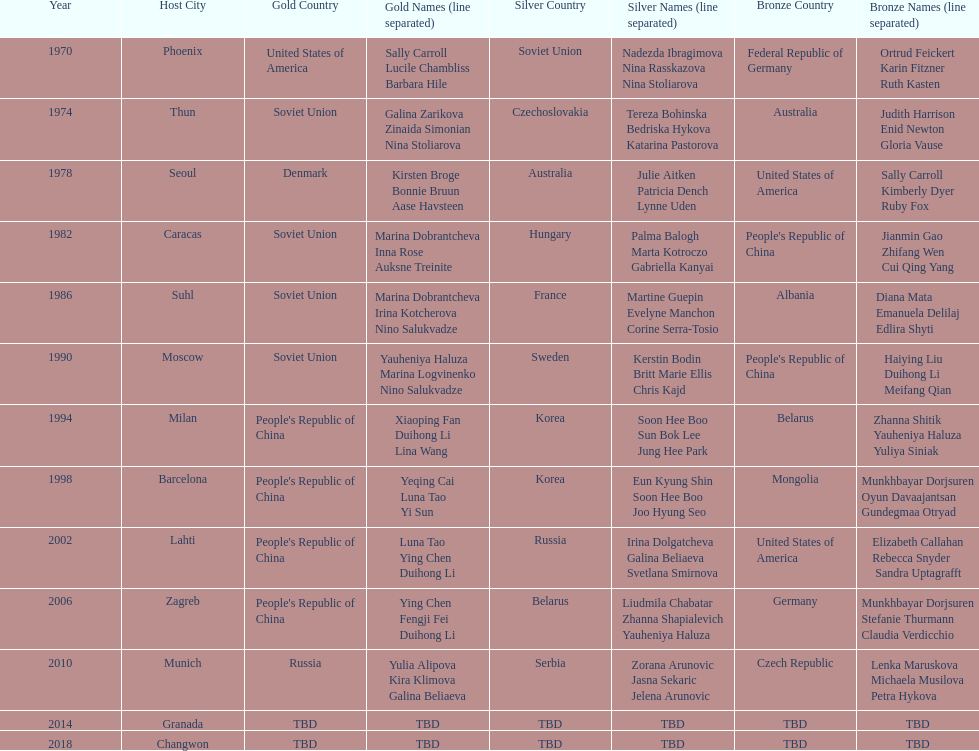What is the first place listed in this chart? Phoenix. 